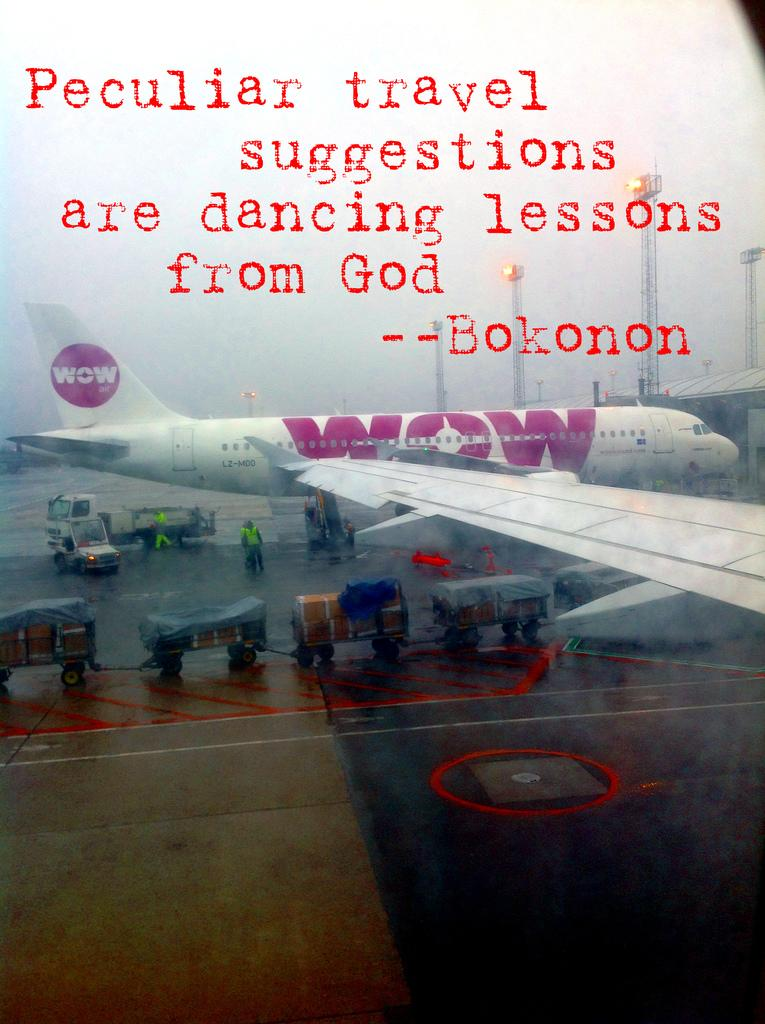<image>
Summarize the visual content of the image. A quote about travel is positioned above a Wow aircraft sitting on near an airport terminal. 